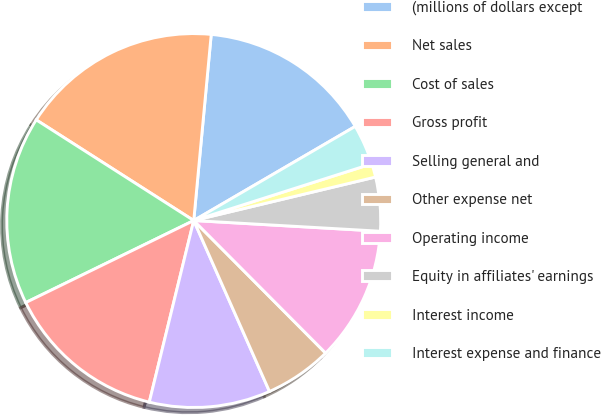Convert chart. <chart><loc_0><loc_0><loc_500><loc_500><pie_chart><fcel>(millions of dollars except<fcel>Net sales<fcel>Cost of sales<fcel>Gross profit<fcel>Selling general and<fcel>Other expense net<fcel>Operating income<fcel>Equity in affiliates' earnings<fcel>Interest income<fcel>Interest expense and finance<nl><fcel>15.11%<fcel>17.44%<fcel>16.28%<fcel>13.95%<fcel>10.46%<fcel>5.82%<fcel>11.63%<fcel>4.65%<fcel>1.17%<fcel>3.49%<nl></chart> 